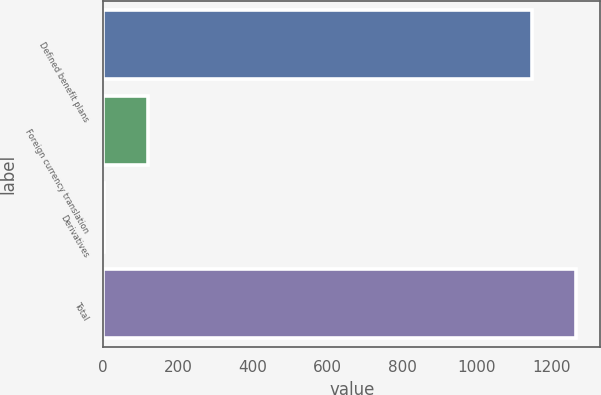Convert chart to OTSL. <chart><loc_0><loc_0><loc_500><loc_500><bar_chart><fcel>Defined benefit plans<fcel>Foreign currency translation<fcel>Derivatives<fcel>Total<nl><fcel>1149<fcel>119.5<fcel>1<fcel>1267.5<nl></chart> 